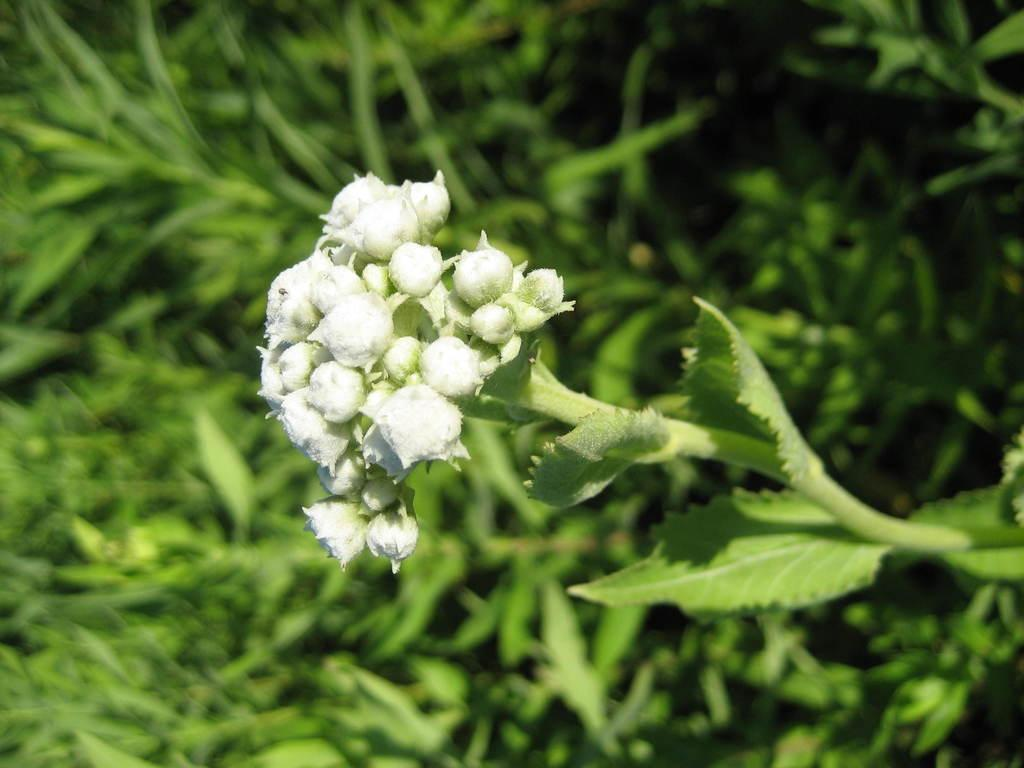What type of living organisms can be seen in the image? Flower buds and plants can be seen in the image. Can you describe the background of the image? The background of the image is blurred. What type of station can be seen in the image? There is no station present in the image; it features flower buds and plants. What type of meal is being prepared in the image? There is no meal being prepared in the image; it features flower buds and plants. How many lizards are visible in the image? There are no lizards present in the image. 